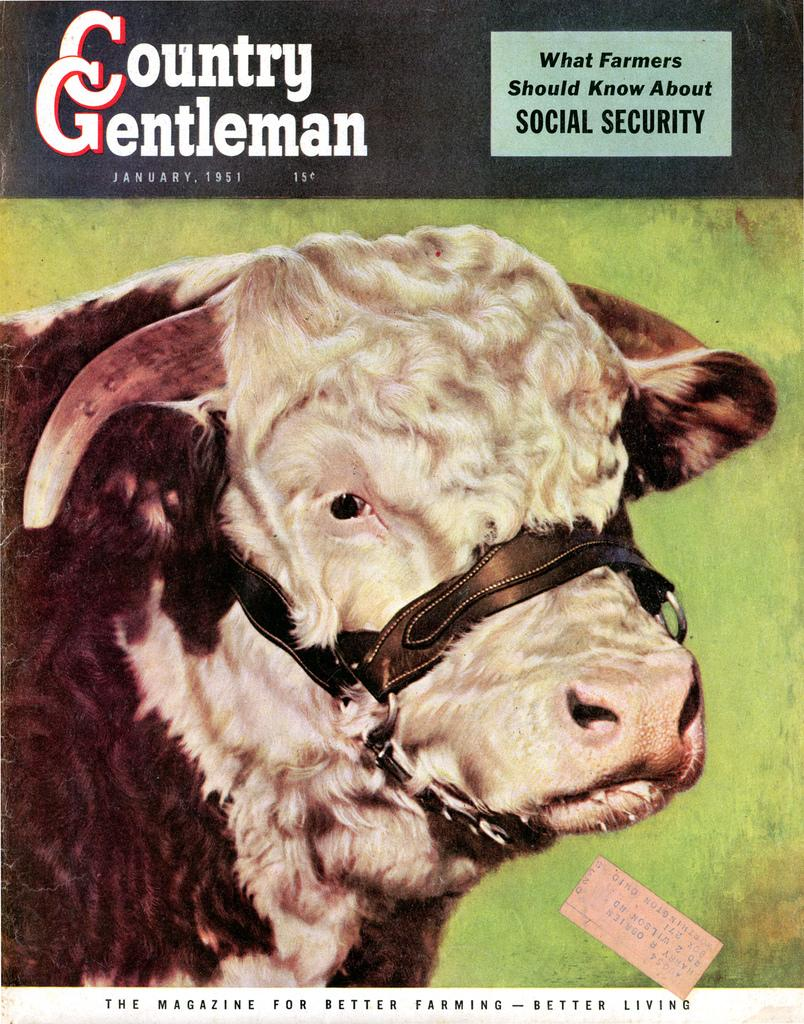What type of living creature is present in the image? There is an animal in the image. What else can be seen in the image besides the animal? There is text in the image. What type of yam is being used to create the text in the image? There is no yam present in the image, and the text is not created using any yam. 